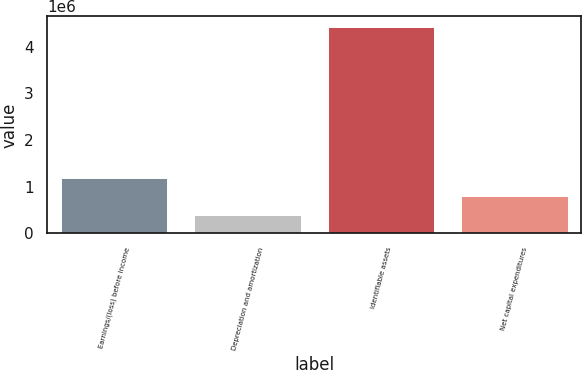<chart> <loc_0><loc_0><loc_500><loc_500><bar_chart><fcel>Earnings/(loss) before income<fcel>Depreciation and amortization<fcel>Identifiable assets<fcel>Net capital expenditures<nl><fcel>1.19556e+06<fcel>387211<fcel>4.42894e+06<fcel>791384<nl></chart> 